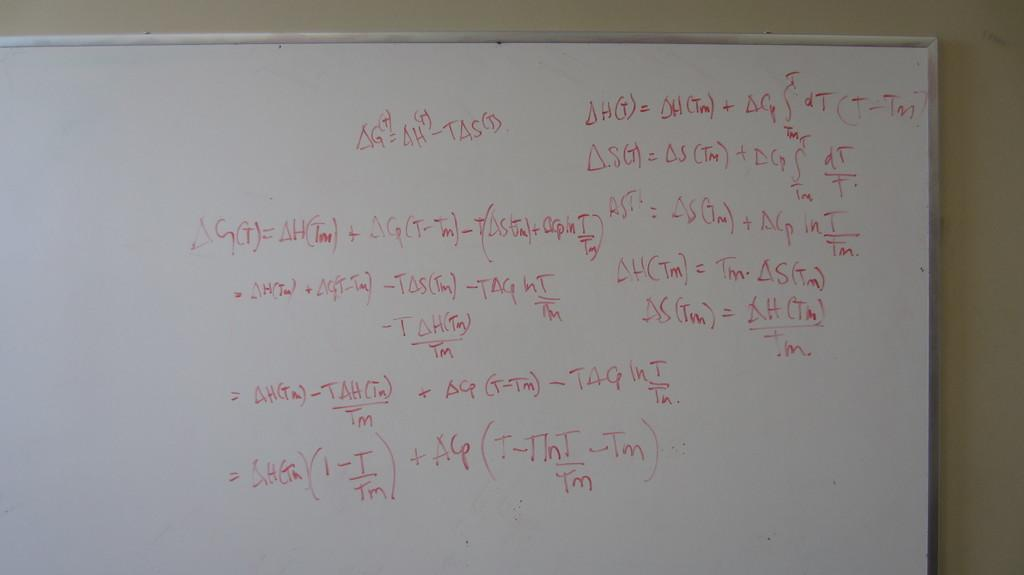<image>
Write a terse but informative summary of the picture. A white board with various alegebra calculations written on it. 